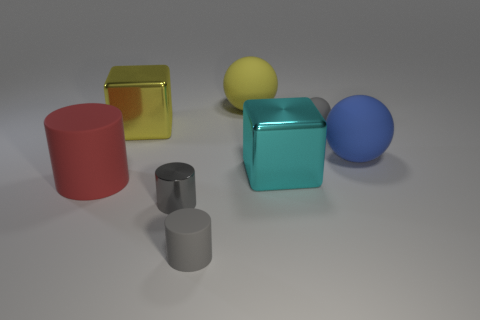Is the shape of the big thing that is right of the cyan metallic object the same as  the yellow rubber thing?
Ensure brevity in your answer.  Yes. What color is the cube left of the large sphere behind the big metallic thing left of the big cyan metallic block?
Your response must be concise. Yellow. Are there any big green rubber spheres?
Make the answer very short. No. What number of other objects are the same size as the metal cylinder?
Offer a very short reply. 2. There is a small shiny object; does it have the same color as the tiny thing that is behind the large cyan block?
Make the answer very short. Yes. How many objects are large red matte objects or big red rubber balls?
Offer a terse response. 1. Are there any other things of the same color as the tiny rubber ball?
Provide a short and direct response. Yes. Is the material of the big cylinder the same as the gray thing that is behind the red matte cylinder?
Keep it short and to the point. Yes. There is a small gray matte object that is on the right side of the gray rubber object in front of the large matte cylinder; what shape is it?
Your response must be concise. Sphere. There is a rubber thing that is both left of the small gray sphere and behind the cyan block; what is its shape?
Provide a succinct answer. Sphere. 